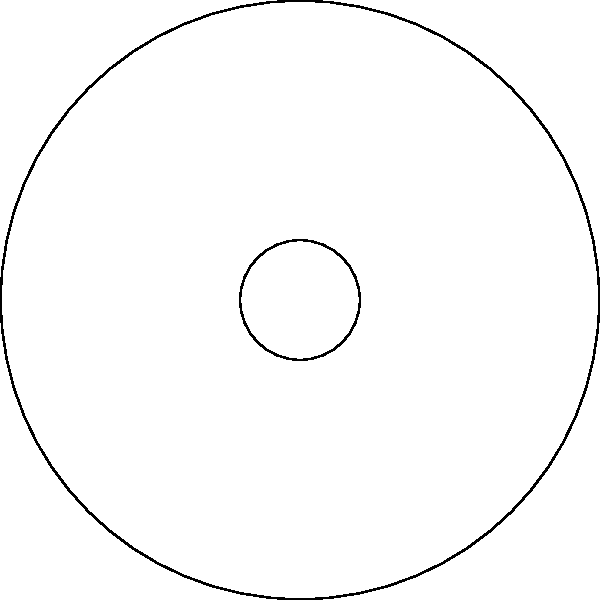As a commuter who appreciates punctuality, you've noticed the bus wheel has a unique design with 6 spokes. If the wheel is rotated by 120°, how many spokes will appear to be in the same position as before the rotation? Let's approach this step-by-step:

1) First, we need to understand what a rotation of 120° means:
   - A full rotation is 360°
   - 120° is one-third of a full rotation (360° ÷ 3 = 120°)

2) Now, let's consider the symmetry of the wheel:
   - The wheel has 6 spokes
   - The angle between each spoke is 60° (360° ÷ 6 = 60°)

3) When we rotate by 120°:
   - This is equivalent to rotating by 2 spoke positions (120° ÷ 60° = 2)

4) To find which spokes are in the same position:
   - Spoke 1 rotates to the position of spoke 3
   - Spoke 2 rotates to the position of spoke 4
   - Spoke 3 rotates to the position of spoke 5
   - Spoke 4 rotates to the position of spoke 6
   - Spoke 5 rotates to the position of spoke 1
   - Spoke 6 rotates to the position of spoke 2

5) We can see that spokes 1 and 4, 2 and 5, 3 and 6 swap positions

Therefore, every other spoke (1, 3, 5) will appear to be in the same position as a different spoke was before the rotation.
Answer: 3 spokes 